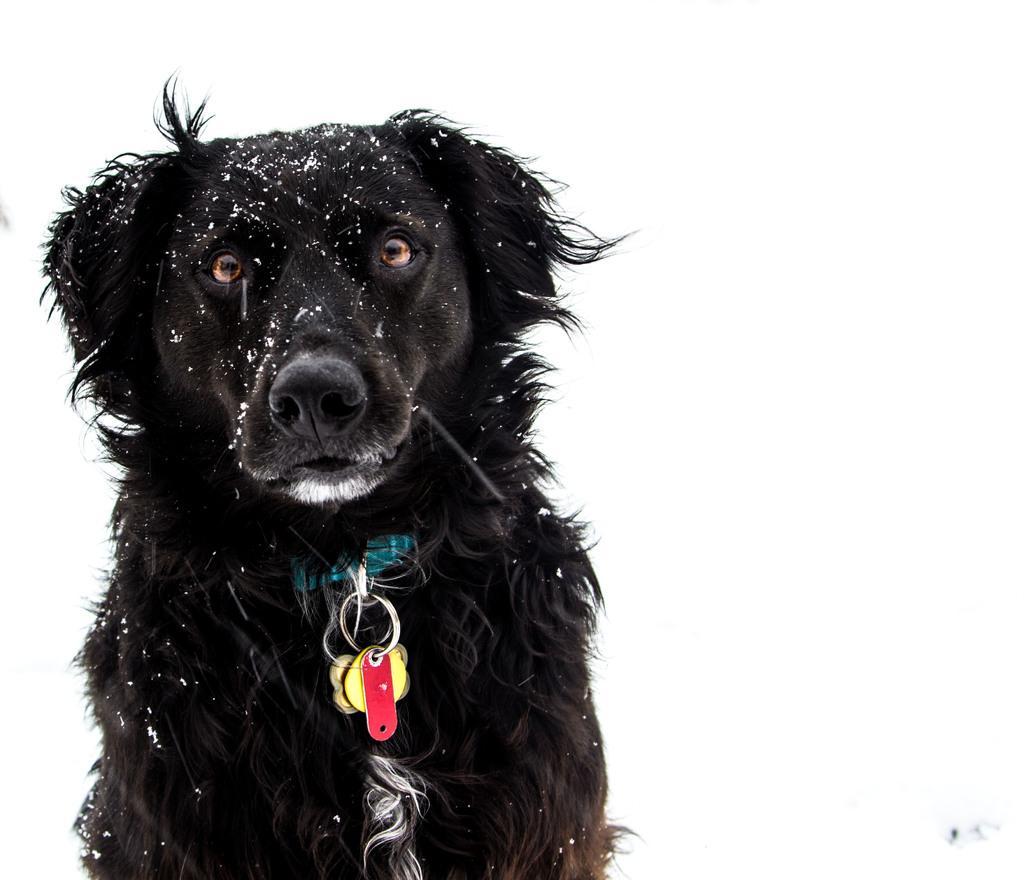Describe this image in one or two sentences. In this image we can see there is a dog with a chain. And at the back there is a white background. 